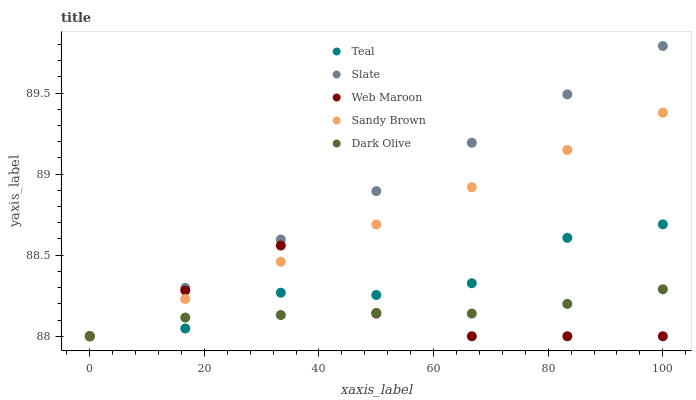Does Dark Olive have the minimum area under the curve?
Answer yes or no. Yes. Does Slate have the maximum area under the curve?
Answer yes or no. Yes. Does Slate have the minimum area under the curve?
Answer yes or no. No. Does Dark Olive have the maximum area under the curve?
Answer yes or no. No. Is Sandy Brown the smoothest?
Answer yes or no. Yes. Is Web Maroon the roughest?
Answer yes or no. Yes. Is Slate the smoothest?
Answer yes or no. No. Is Slate the roughest?
Answer yes or no. No. Does Sandy Brown have the lowest value?
Answer yes or no. Yes. Does Slate have the highest value?
Answer yes or no. Yes. Does Dark Olive have the highest value?
Answer yes or no. No. Does Web Maroon intersect Slate?
Answer yes or no. Yes. Is Web Maroon less than Slate?
Answer yes or no. No. Is Web Maroon greater than Slate?
Answer yes or no. No. 